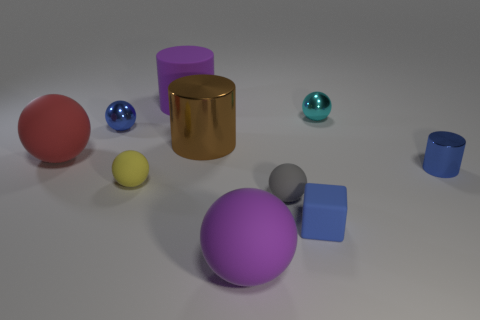What color is the rubber sphere that is on the left side of the blue shiny thing to the left of the small blue metallic object that is to the right of the small blue ball?
Provide a succinct answer. Red. Does the big purple rubber object behind the gray rubber ball have the same shape as the brown object?
Provide a succinct answer. Yes. What number of large brown things are there?
Your response must be concise. 1. What number of rubber cubes have the same size as the gray rubber ball?
Your answer should be very brief. 1. What is the material of the tiny blue cylinder?
Make the answer very short. Metal. Do the matte block and the metal sphere that is on the left side of the small gray thing have the same color?
Your answer should be compact. Yes. Is there any other thing that has the same size as the purple rubber sphere?
Make the answer very short. Yes. What is the size of the metal object that is both right of the large purple matte cylinder and to the left of the cube?
Your answer should be compact. Large. What shape is the big thing that is made of the same material as the cyan sphere?
Keep it short and to the point. Cylinder. Does the purple cylinder have the same material as the big purple thing in front of the cyan metallic thing?
Provide a succinct answer. Yes. 